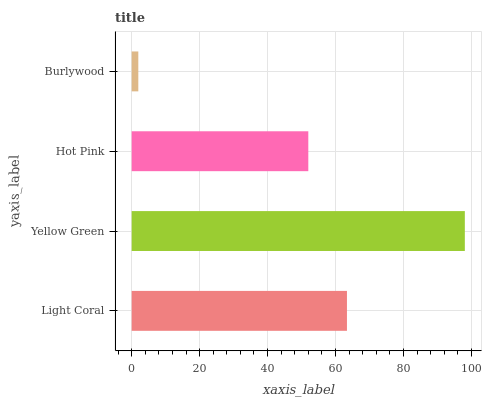Is Burlywood the minimum?
Answer yes or no. Yes. Is Yellow Green the maximum?
Answer yes or no. Yes. Is Hot Pink the minimum?
Answer yes or no. No. Is Hot Pink the maximum?
Answer yes or no. No. Is Yellow Green greater than Hot Pink?
Answer yes or no. Yes. Is Hot Pink less than Yellow Green?
Answer yes or no. Yes. Is Hot Pink greater than Yellow Green?
Answer yes or no. No. Is Yellow Green less than Hot Pink?
Answer yes or no. No. Is Light Coral the high median?
Answer yes or no. Yes. Is Hot Pink the low median?
Answer yes or no. Yes. Is Yellow Green the high median?
Answer yes or no. No. Is Light Coral the low median?
Answer yes or no. No. 